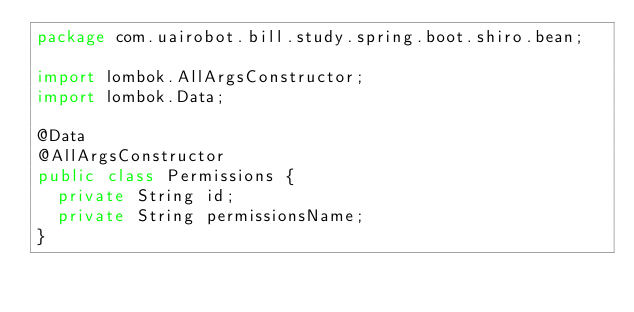<code> <loc_0><loc_0><loc_500><loc_500><_Java_>package com.uairobot.bill.study.spring.boot.shiro.bean;

import lombok.AllArgsConstructor;
import lombok.Data;

@Data
@AllArgsConstructor
public class Permissions {
  private String id;
  private String permissionsName;
}</code> 